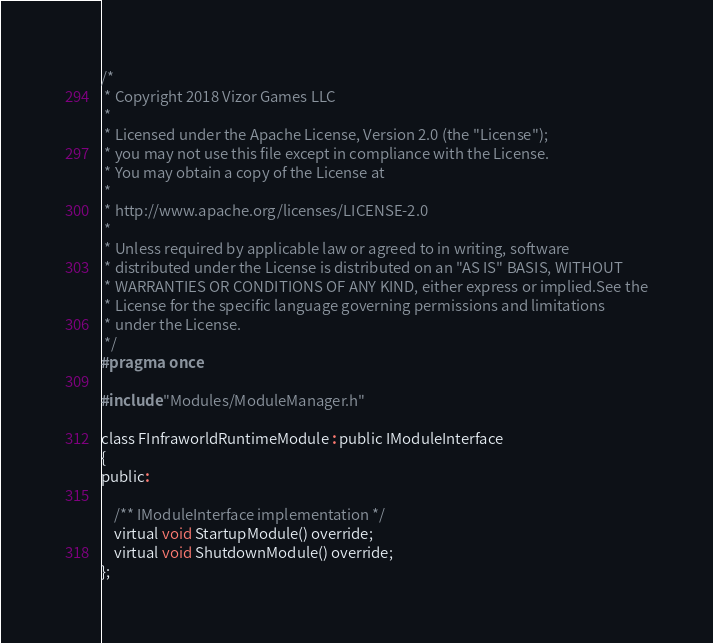<code> <loc_0><loc_0><loc_500><loc_500><_C_>/*
 * Copyright 2018 Vizor Games LLC
 *
 * Licensed under the Apache License, Version 2.0 (the "License");
 * you may not use this file except in compliance with the License.
 * You may obtain a copy of the License at
 *
 * http://www.apache.org/licenses/LICENSE-2.0
 *
 * Unless required by applicable law or agreed to in writing, software
 * distributed under the License is distributed on an "AS IS" BASIS, WITHOUT
 * WARRANTIES OR CONDITIONS OF ANY KIND, either express or implied.See the
 * License for the specific language governing permissions and limitations
 * under the License.
 */
#pragma once

#include "Modules/ModuleManager.h"

class FInfraworldRuntimeModule : public IModuleInterface
{
public:

	/** IModuleInterface implementation */
	virtual void StartupModule() override;
	virtual void ShutdownModule() override;
};
</code> 